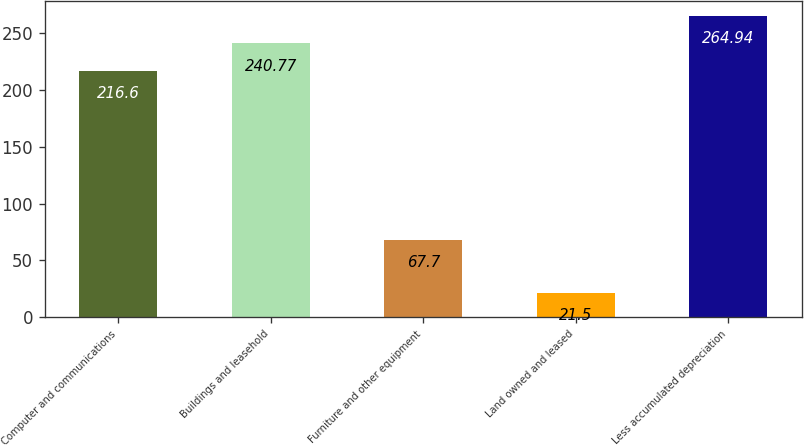Convert chart to OTSL. <chart><loc_0><loc_0><loc_500><loc_500><bar_chart><fcel>Computer and communications<fcel>Buildings and leasehold<fcel>Furniture and other equipment<fcel>Land owned and leased<fcel>Less accumulated depreciation<nl><fcel>216.6<fcel>240.77<fcel>67.7<fcel>21.5<fcel>264.94<nl></chart> 